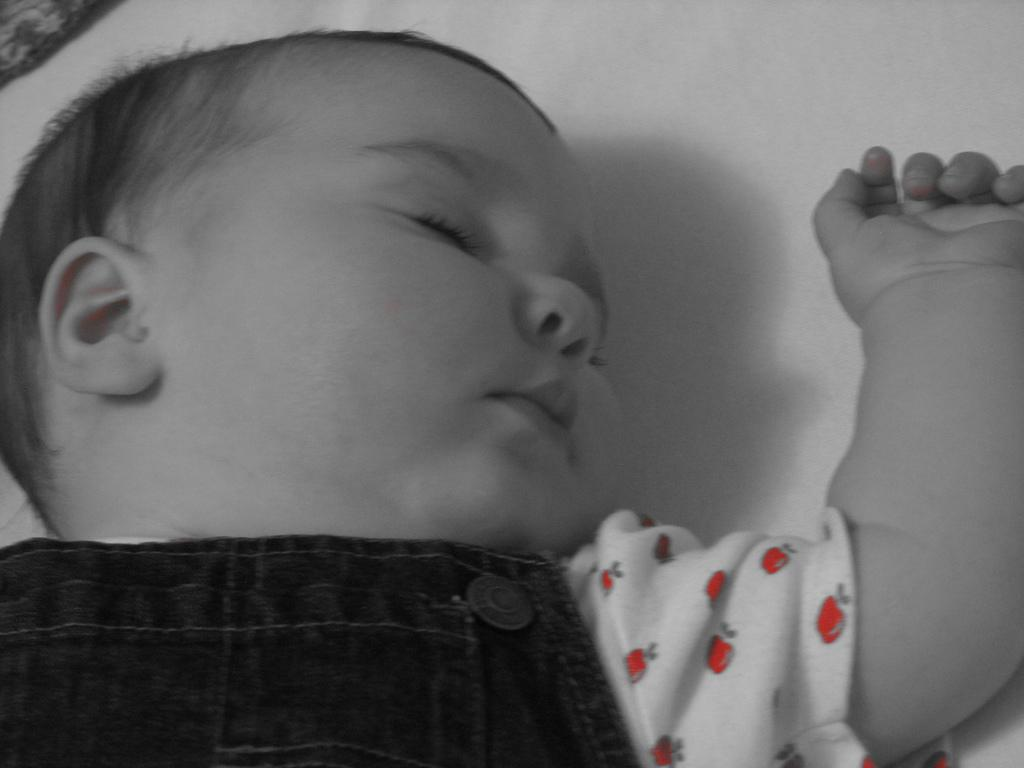What is the main subject of the image? The main subject of the image is a baby. What is the baby doing in the image? The baby is sleeping in the image. What is the baby lying on? The baby is on a white cloth in the image. What historical event is depicted in the image? There is no historical event depicted in the image; it features a sleeping baby on a white cloth. What type of roof is visible in the image? There is no roof visible in the image; it focuses on the baby and the white cloth. 